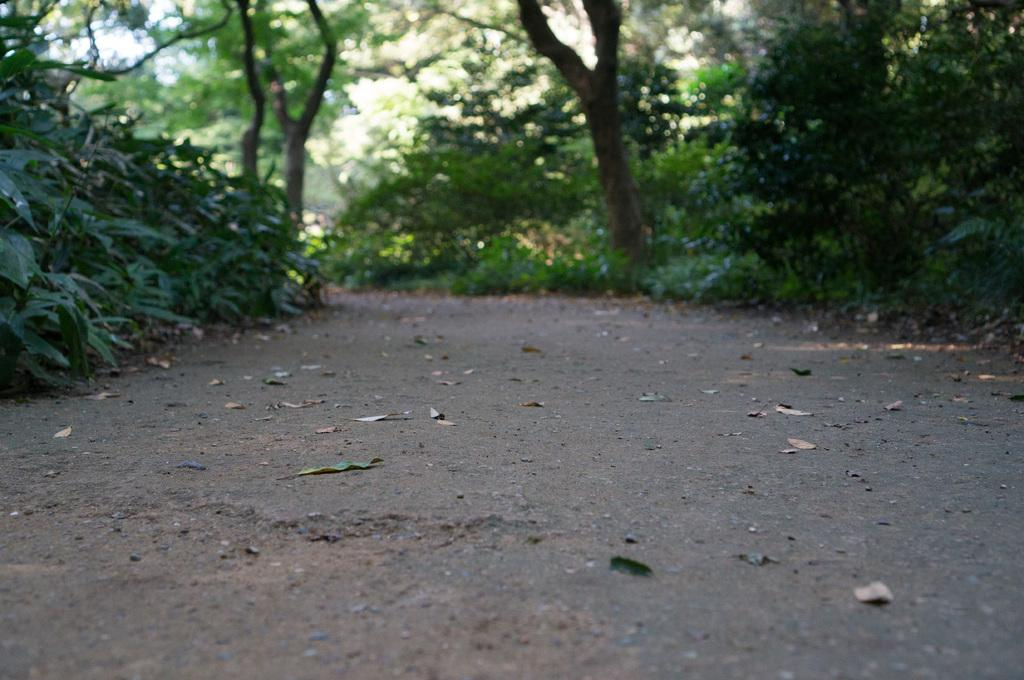What can be seen in the foreground of the image? There are dry leaves and a path in the foreground of the image. What is located in the middle of the image? There are plants and another path in the middle of the image. What is visible in the background of the image? There are trees and the sky in the background of the image. What type of mint can be seen growing along the path in the image? There is no mint present in the image; it features dry leaves, plants, and trees. Is there any blood visible on the path in the image? There is no blood visible in the image; it is a natural scene with dry leaves, plants, and trees. 